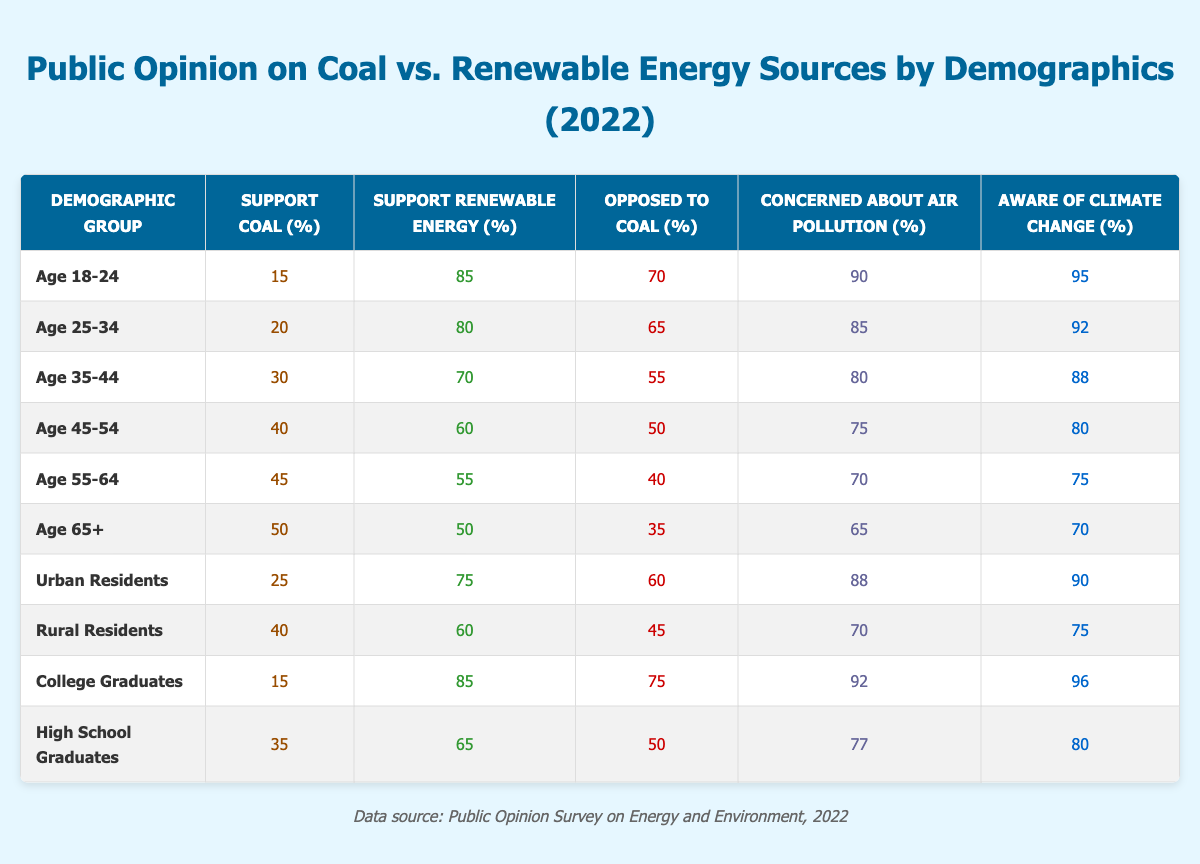What's the percentage of people aged 18-24 who support renewable energy? According to the data, the percentage of people aged 18-24 who support renewable energy is 85%.
Answer: 85% What is the percentage of urban residents who are opposed to coal? The table shows that 60% of urban residents are opposed to coal.
Answer: 60% Which demographic group has the highest percentage opposed to coal, and what is that percentage? The demographic group with the highest percentage opposed to coal is college graduates, with 75%.
Answer: College Graduates: 75% What is the average support for coal among all age groups listed? The support for coal among the age groups is as follows: 15, 20, 30, 40, 45, and 50. Summing these gives 15 + 20 + 30 + 40 + 45 + 50 = 200. There are 6 age groups, so the average is 200 / 6 = 33.33.
Answer: 33.33 Is there a higher awareness of climate change among college graduates or high school graduates? According to the data, college graduates have a climate change awareness of 96%, while high school graduates have 80%. Therefore, college graduates show higher awareness.
Answer: Yes What percentage of rural residents are concerned about air pollution? The table indicates that 70% of rural residents are concerned about air pollution.
Answer: 70% Which age demographic has the least support for coal and what is that percentage? The age demographic with the least support for coal is aged 18-24, with only 15% supporting coal.
Answer: Age 18-24: 15% What is the difference in support for renewable energy between the age groups 25-34 and 45-54? The support for renewable energy for age 25-34 is 80%, while for age 45-54, it's 60%. The difference is 80 - 60 = 20%.
Answer: 20% Among the demographic groups listed, who shows the lowest concern about air pollution, and what is that percentage? The demographic group showing the lowest concern about air pollution is age 65+, with 65% concerned.
Answer: Age 65+: 65% If we compare the average support for renewable energy between urban and rural residents, which group has a higher average? Urban residents support renewable energy at 75%, while rural residents support it at 60%. Therefore, urban residents have a higher average support for renewable energy.
Answer: Urban Residents 